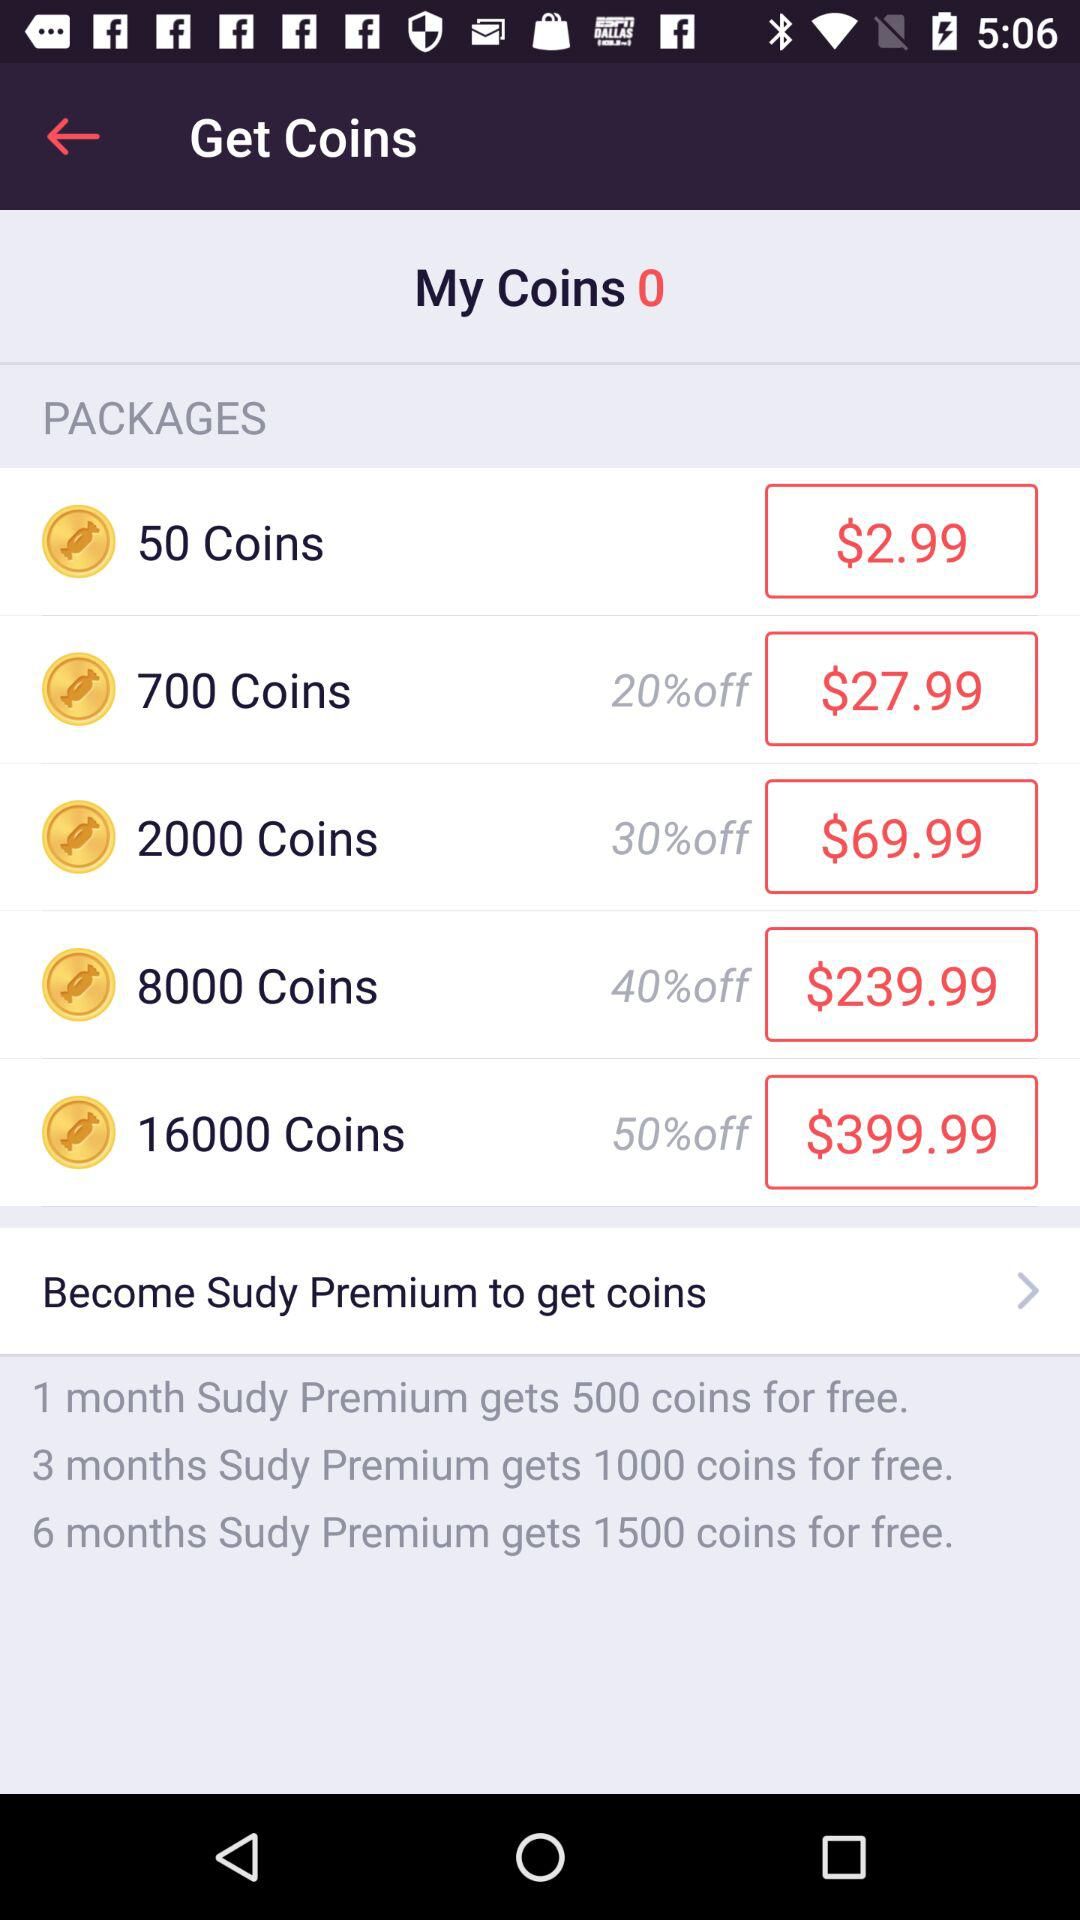What does a Sudy Premium member get in 6 months? In six months, a Sudy Premium member gets 1500 coins for free. 